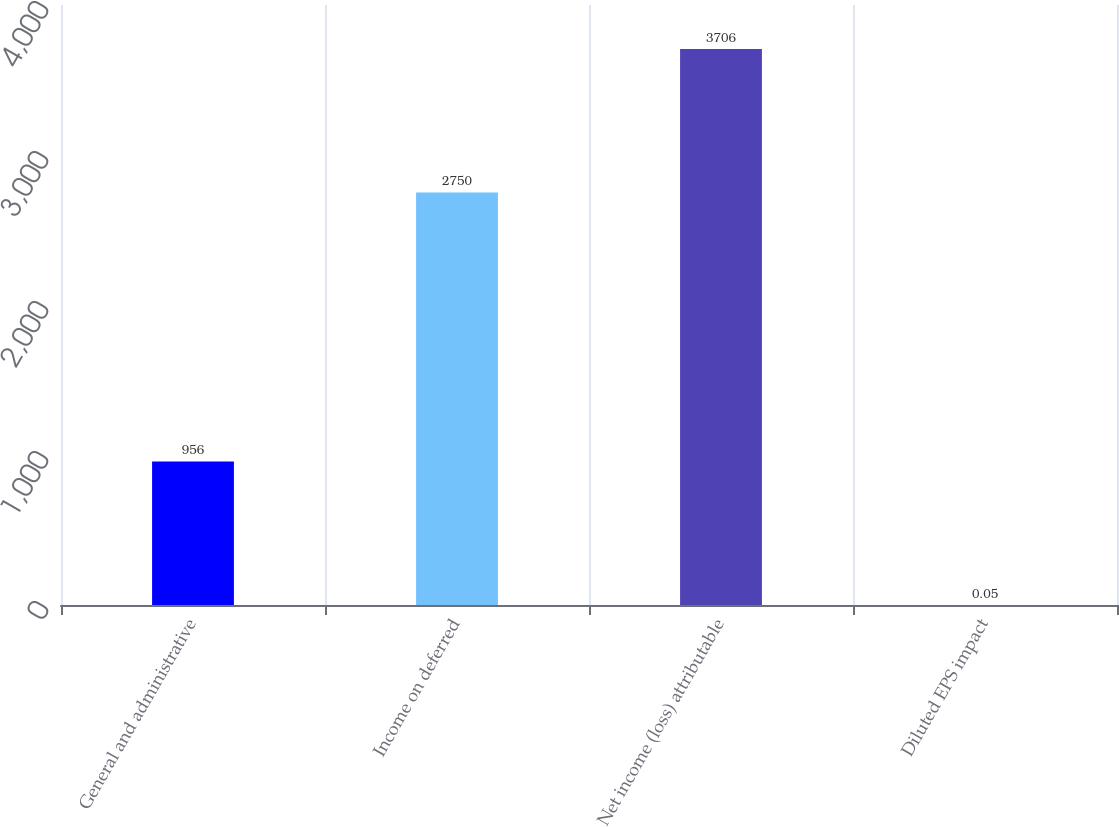Convert chart to OTSL. <chart><loc_0><loc_0><loc_500><loc_500><bar_chart><fcel>General and administrative<fcel>Income on deferred<fcel>Net income (loss) attributable<fcel>Diluted EPS impact<nl><fcel>956<fcel>2750<fcel>3706<fcel>0.05<nl></chart> 